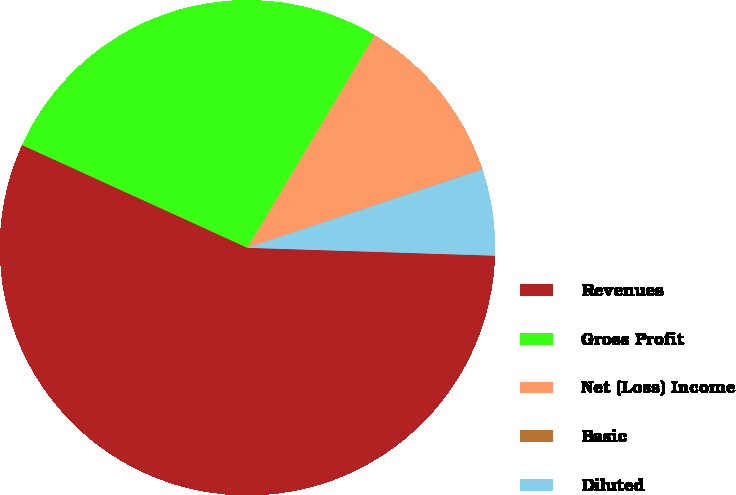<chart> <loc_0><loc_0><loc_500><loc_500><pie_chart><fcel>Revenues<fcel>Gross Profit<fcel>Net (Loss) Income<fcel>Basic<fcel>Diluted<nl><fcel>56.3%<fcel>26.78%<fcel>11.27%<fcel>0.01%<fcel>5.64%<nl></chart> 